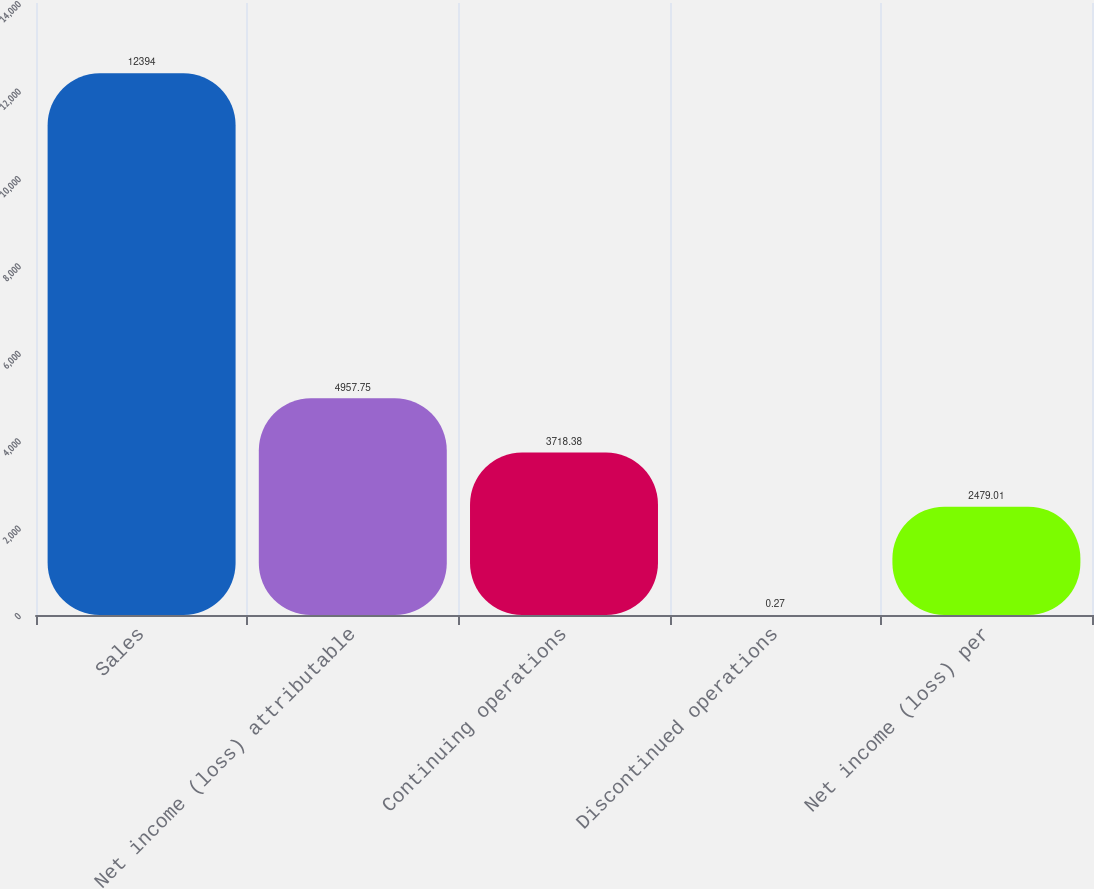Convert chart to OTSL. <chart><loc_0><loc_0><loc_500><loc_500><bar_chart><fcel>Sales<fcel>Net income (loss) attributable<fcel>Continuing operations<fcel>Discontinued operations<fcel>Net income (loss) per<nl><fcel>12394<fcel>4957.75<fcel>3718.38<fcel>0.27<fcel>2479.01<nl></chart> 